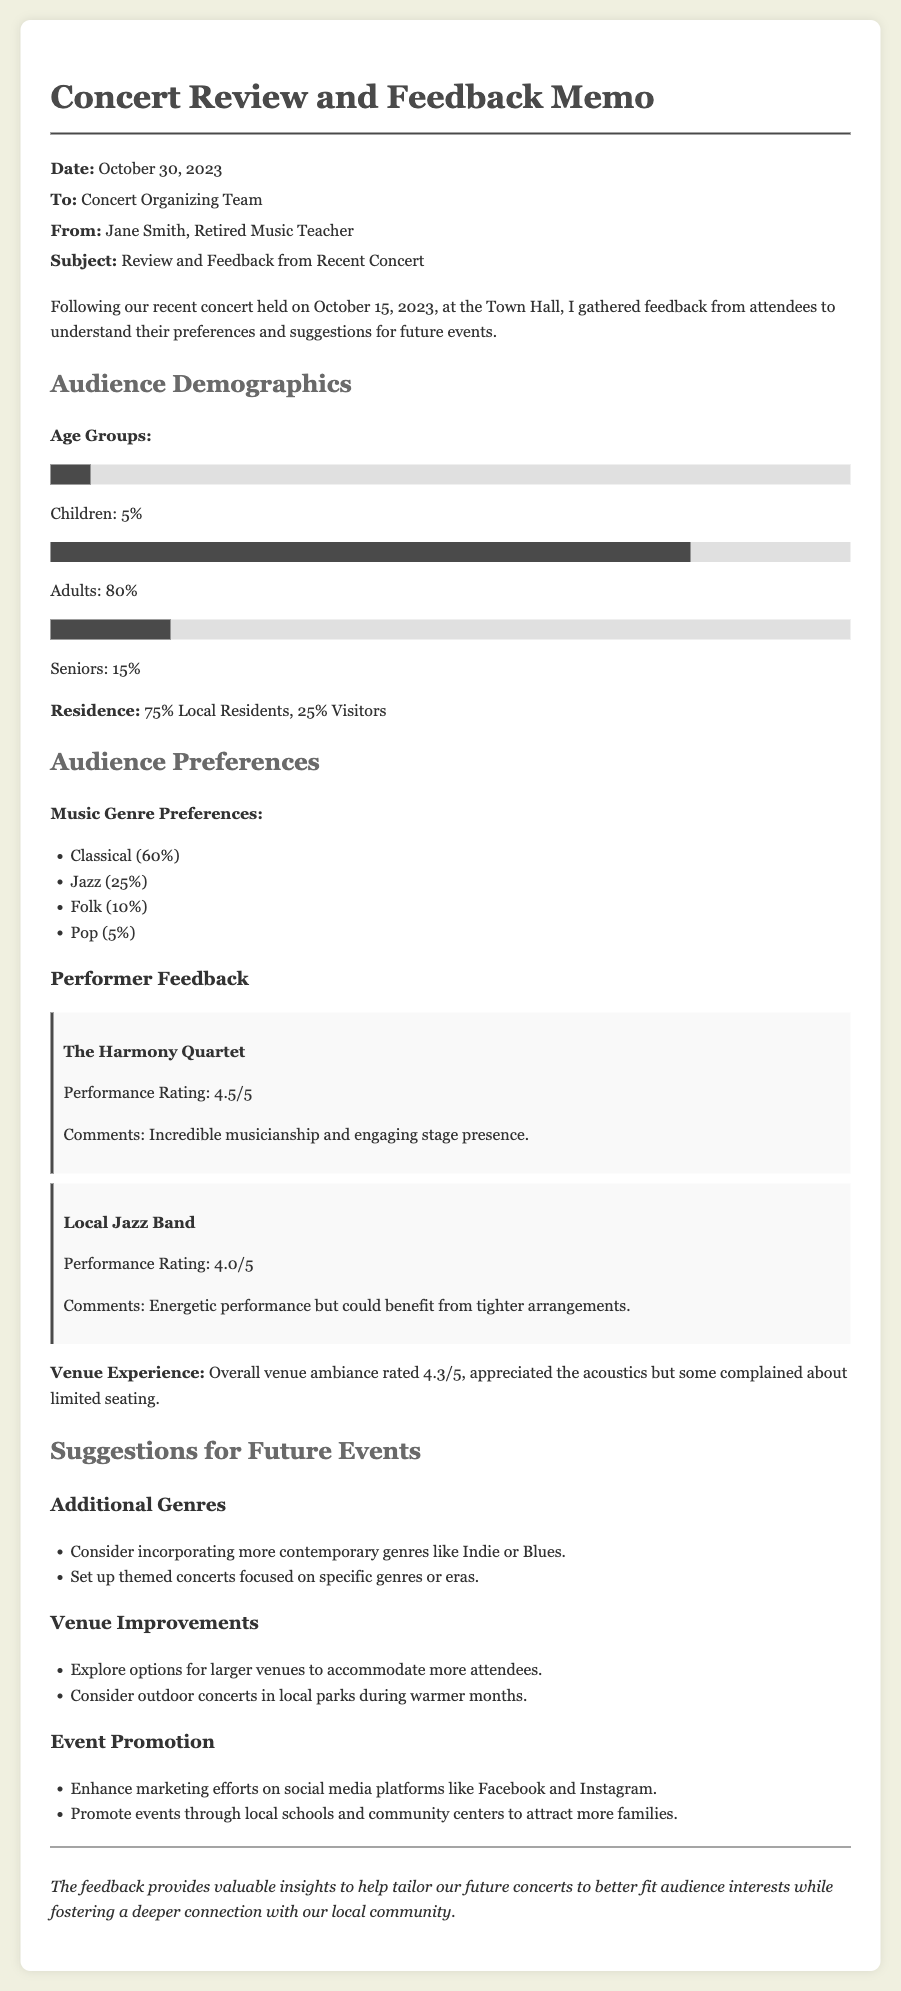what date was the concert held? The concert took place on October 15, 2023, as mentioned in the introduction.
Answer: October 15, 2023 what percentage of attendees were adults? The document states that 80% of attendees were adults, which can be found in the audience demographics section.
Answer: 80% who performed with a rating of 4.5 out of 5? The Harmony Quartet received a performance rating of 4.5 out of 5, which is highlighted under performer feedback.
Answer: The Harmony Quartet what genre received the highest preference percentage? The document indicates that Classical music had the highest preference among attendees at 60%, found in the audience preferences section.
Answer: Classical what suggestion was made regarding venue improvements? The feedback section suggests exploring options for larger venues to accommodate more attendees, indicating a desire for more space.
Answer: Explore options for larger venues how did the audience rate the overall venue ambiance? The overall venue ambiance is rated 4.3 out of 5, as detailed in the audience preferences section.
Answer: 4.3/5 what type of events does the memo recommend enhancing marketing efforts for? The memo suggests enhancing marketing efforts for concerts, as indicated in the event promotion section.
Answer: Concerts how many percent of attendees were local residents? 75% of attendees were local residents, which is specified in the audience demographics section.
Answer: 75% 